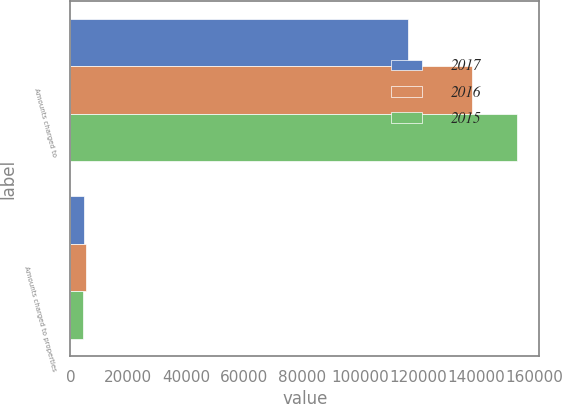Convert chart. <chart><loc_0><loc_0><loc_500><loc_500><stacked_bar_chart><ecel><fcel>Amounts charged to<fcel>Amounts charged to properties<nl><fcel>2017<fcel>116447<fcel>4812<nl><fcel>2016<fcel>138496<fcel>5384<nl><fcel>2015<fcel>154098<fcel>4324<nl></chart> 